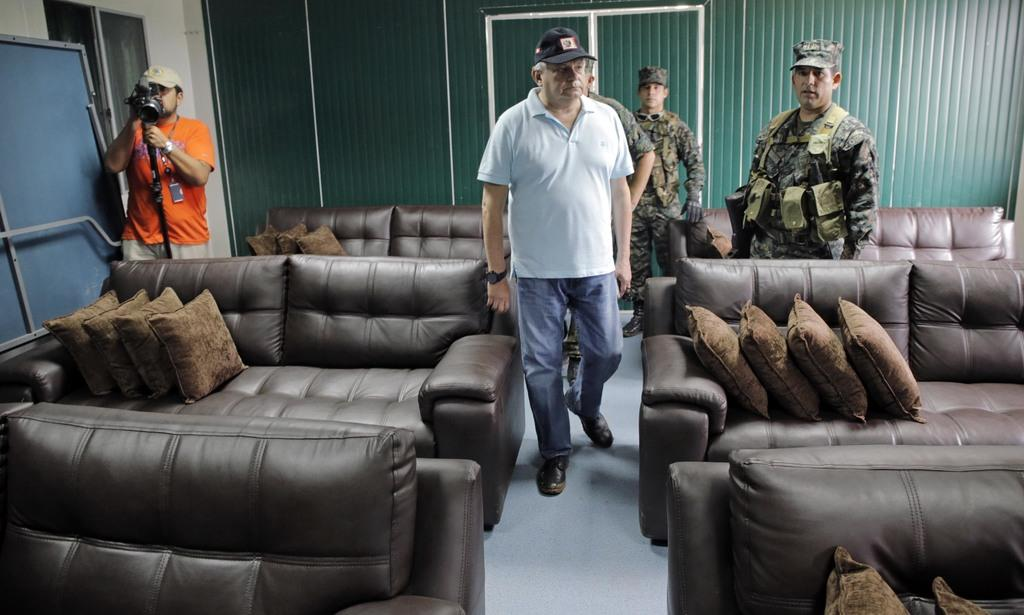What type of people can be seen in the image? There is a group of military people in the image. What are the military people doing in the image? The military people are standing. Where is the person with the video camera located in the image? The person with the video camera is at the left side of the image. What is the person with the video camera doing? The person with the video camera is shooting everything. What type of furniture is present in the image? There are lots of couches present in the image. Can you tell me how many cacti are in the image? There are no cacti present in the image. What type of corn is being served on the couches in the image? There is no corn present in the image, and the couches are not serving any food. 